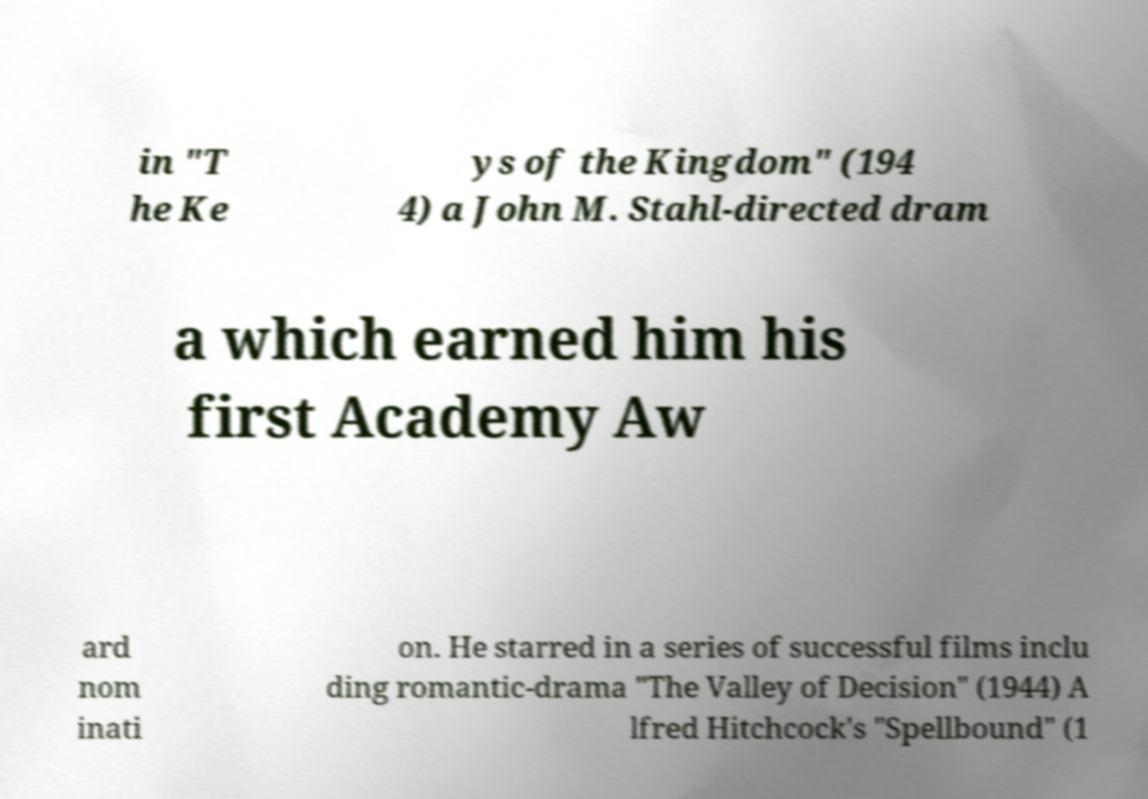What messages or text are displayed in this image? I need them in a readable, typed format. in "T he Ke ys of the Kingdom" (194 4) a John M. Stahl-directed dram a which earned him his first Academy Aw ard nom inati on. He starred in a series of successful films inclu ding romantic-drama "The Valley of Decision" (1944) A lfred Hitchcock's "Spellbound" (1 